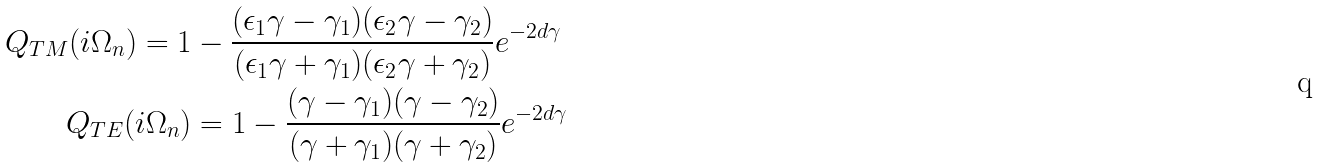Convert formula to latex. <formula><loc_0><loc_0><loc_500><loc_500>Q _ { T M } ( i \Omega _ { n } ) = 1 & - \frac { ( \epsilon _ { 1 } \gamma - \gamma _ { 1 } ) ( \epsilon _ { 2 } \gamma - \gamma _ { 2 } ) } { ( \epsilon _ { 1 } \gamma + \gamma _ { 1 } ) ( \epsilon _ { 2 } \gamma + \gamma _ { 2 } ) } e ^ { - 2 d \gamma } \\ Q _ { T E } ( i \Omega _ { n } ) & = 1 - \frac { ( \gamma - \gamma _ { 1 } ) ( \gamma - \gamma _ { 2 } ) } { ( \gamma + \gamma _ { 1 } ) ( \gamma + \gamma _ { 2 } ) } e ^ { - 2 d \gamma }</formula> 